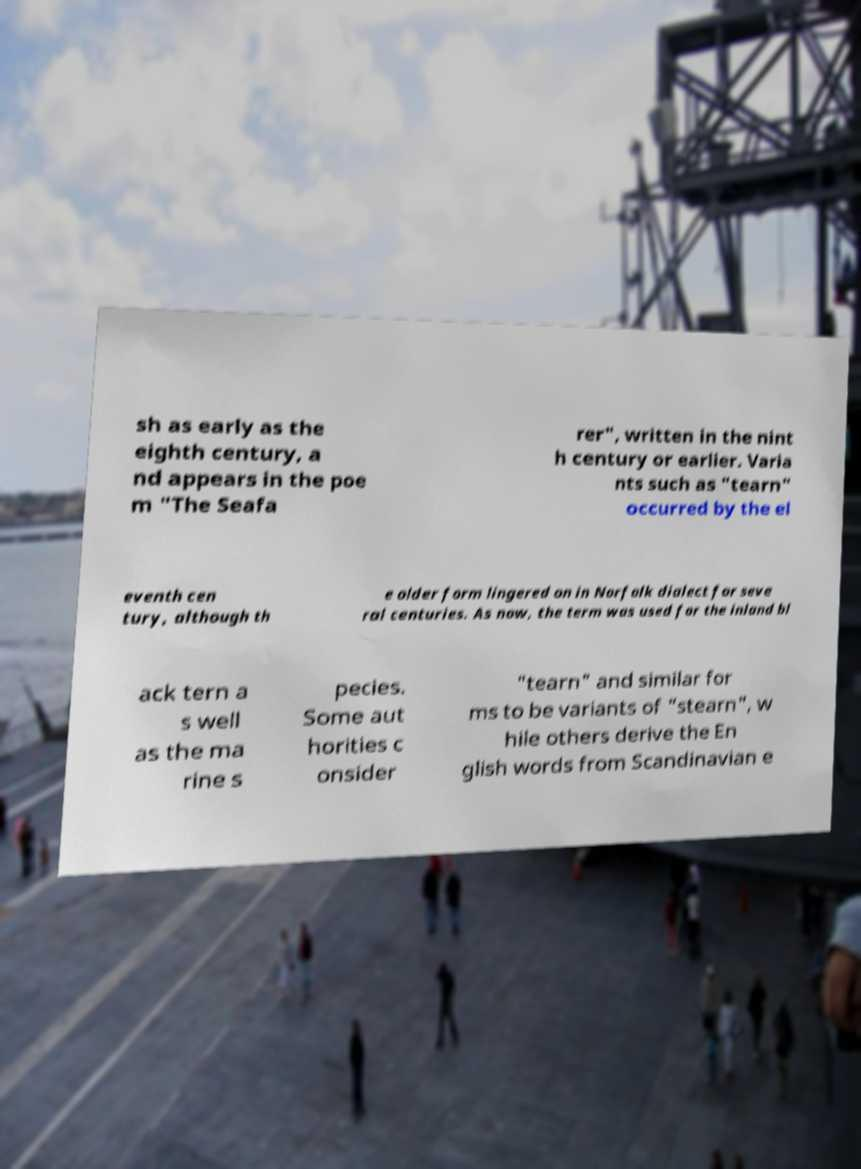There's text embedded in this image that I need extracted. Can you transcribe it verbatim? sh as early as the eighth century, a nd appears in the poe m "The Seafa rer", written in the nint h century or earlier. Varia nts such as "tearn" occurred by the el eventh cen tury, although th e older form lingered on in Norfolk dialect for seve ral centuries. As now, the term was used for the inland bl ack tern a s well as the ma rine s pecies. Some aut horities c onsider "tearn" and similar for ms to be variants of "stearn", w hile others derive the En glish words from Scandinavian e 